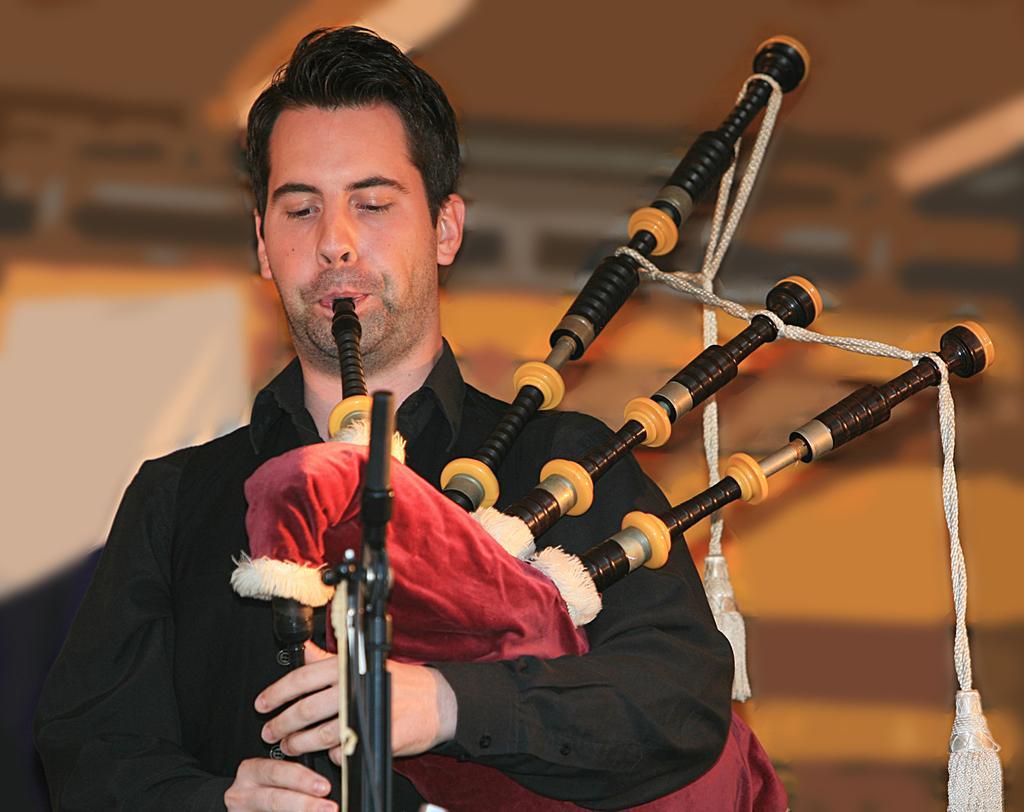Could you give a brief overview of what you see in this image? In this picture we can see a person playing bagpipes, in front of him there is a stand. The background is blurred. 